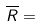<formula> <loc_0><loc_0><loc_500><loc_500>\overline { R } =</formula> 